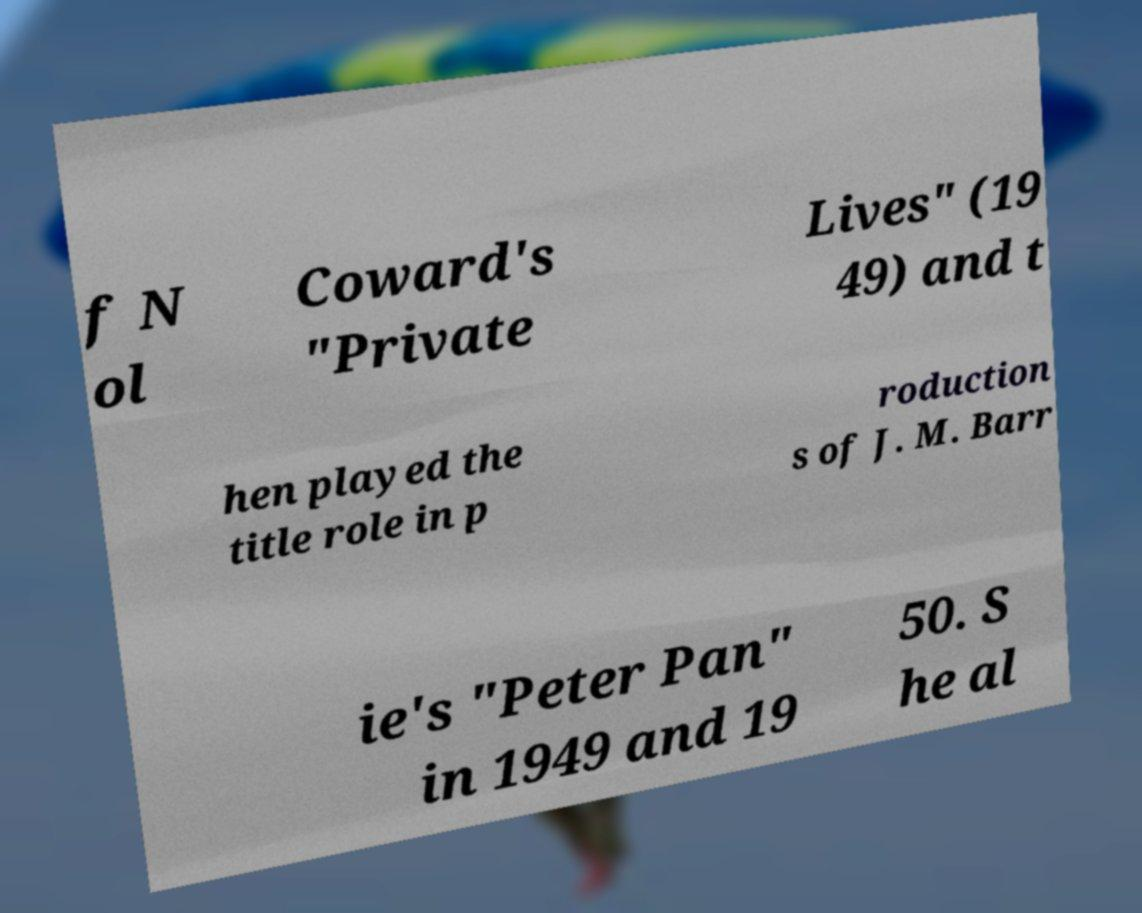What messages or text are displayed in this image? I need them in a readable, typed format. f N ol Coward's "Private Lives" (19 49) and t hen played the title role in p roduction s of J. M. Barr ie's "Peter Pan" in 1949 and 19 50. S he al 